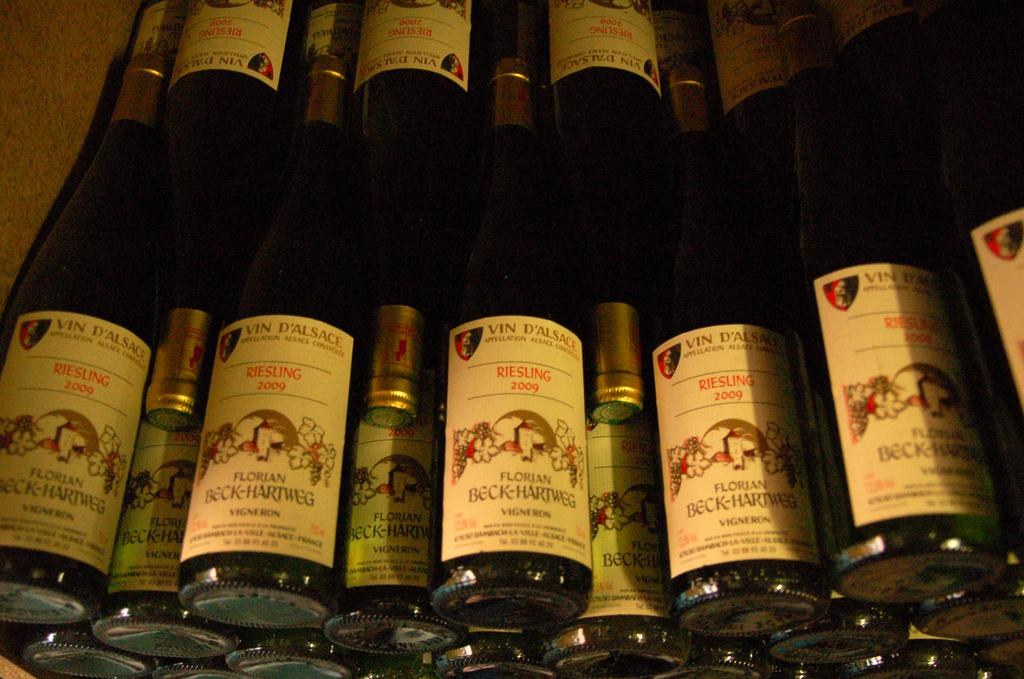<image>
Provide a brief description of the given image. Several bottles of Vin D'Alsace Riesling from 2009 stacked on top of each other. 